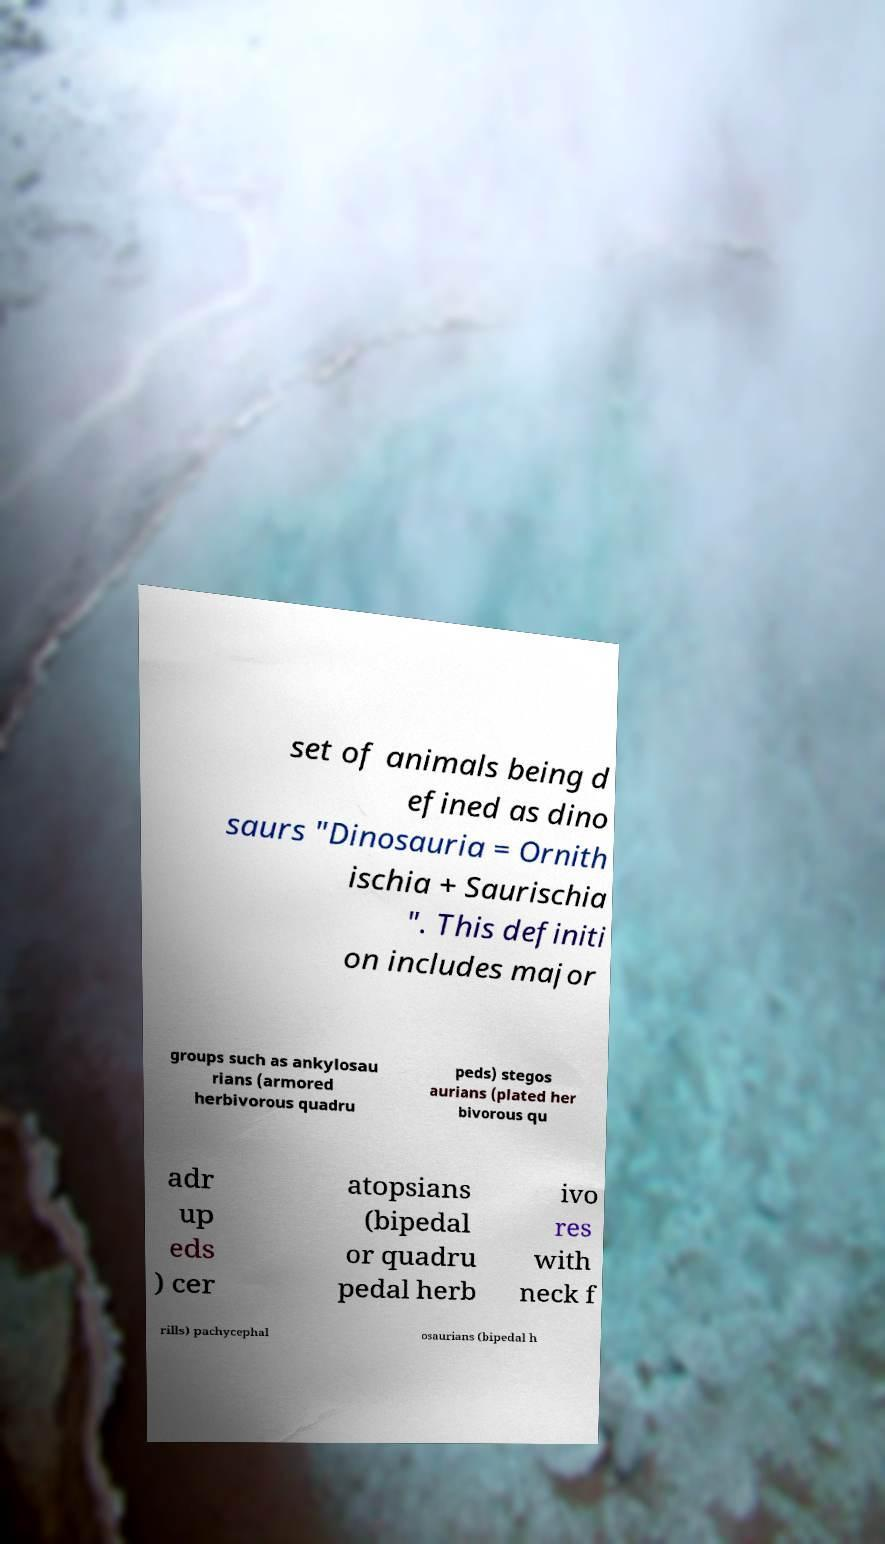For documentation purposes, I need the text within this image transcribed. Could you provide that? set of animals being d efined as dino saurs "Dinosauria = Ornith ischia + Saurischia ". This definiti on includes major groups such as ankylosau rians (armored herbivorous quadru peds) stegos aurians (plated her bivorous qu adr up eds ) cer atopsians (bipedal or quadru pedal herb ivo res with neck f rills) pachycephal osaurians (bipedal h 